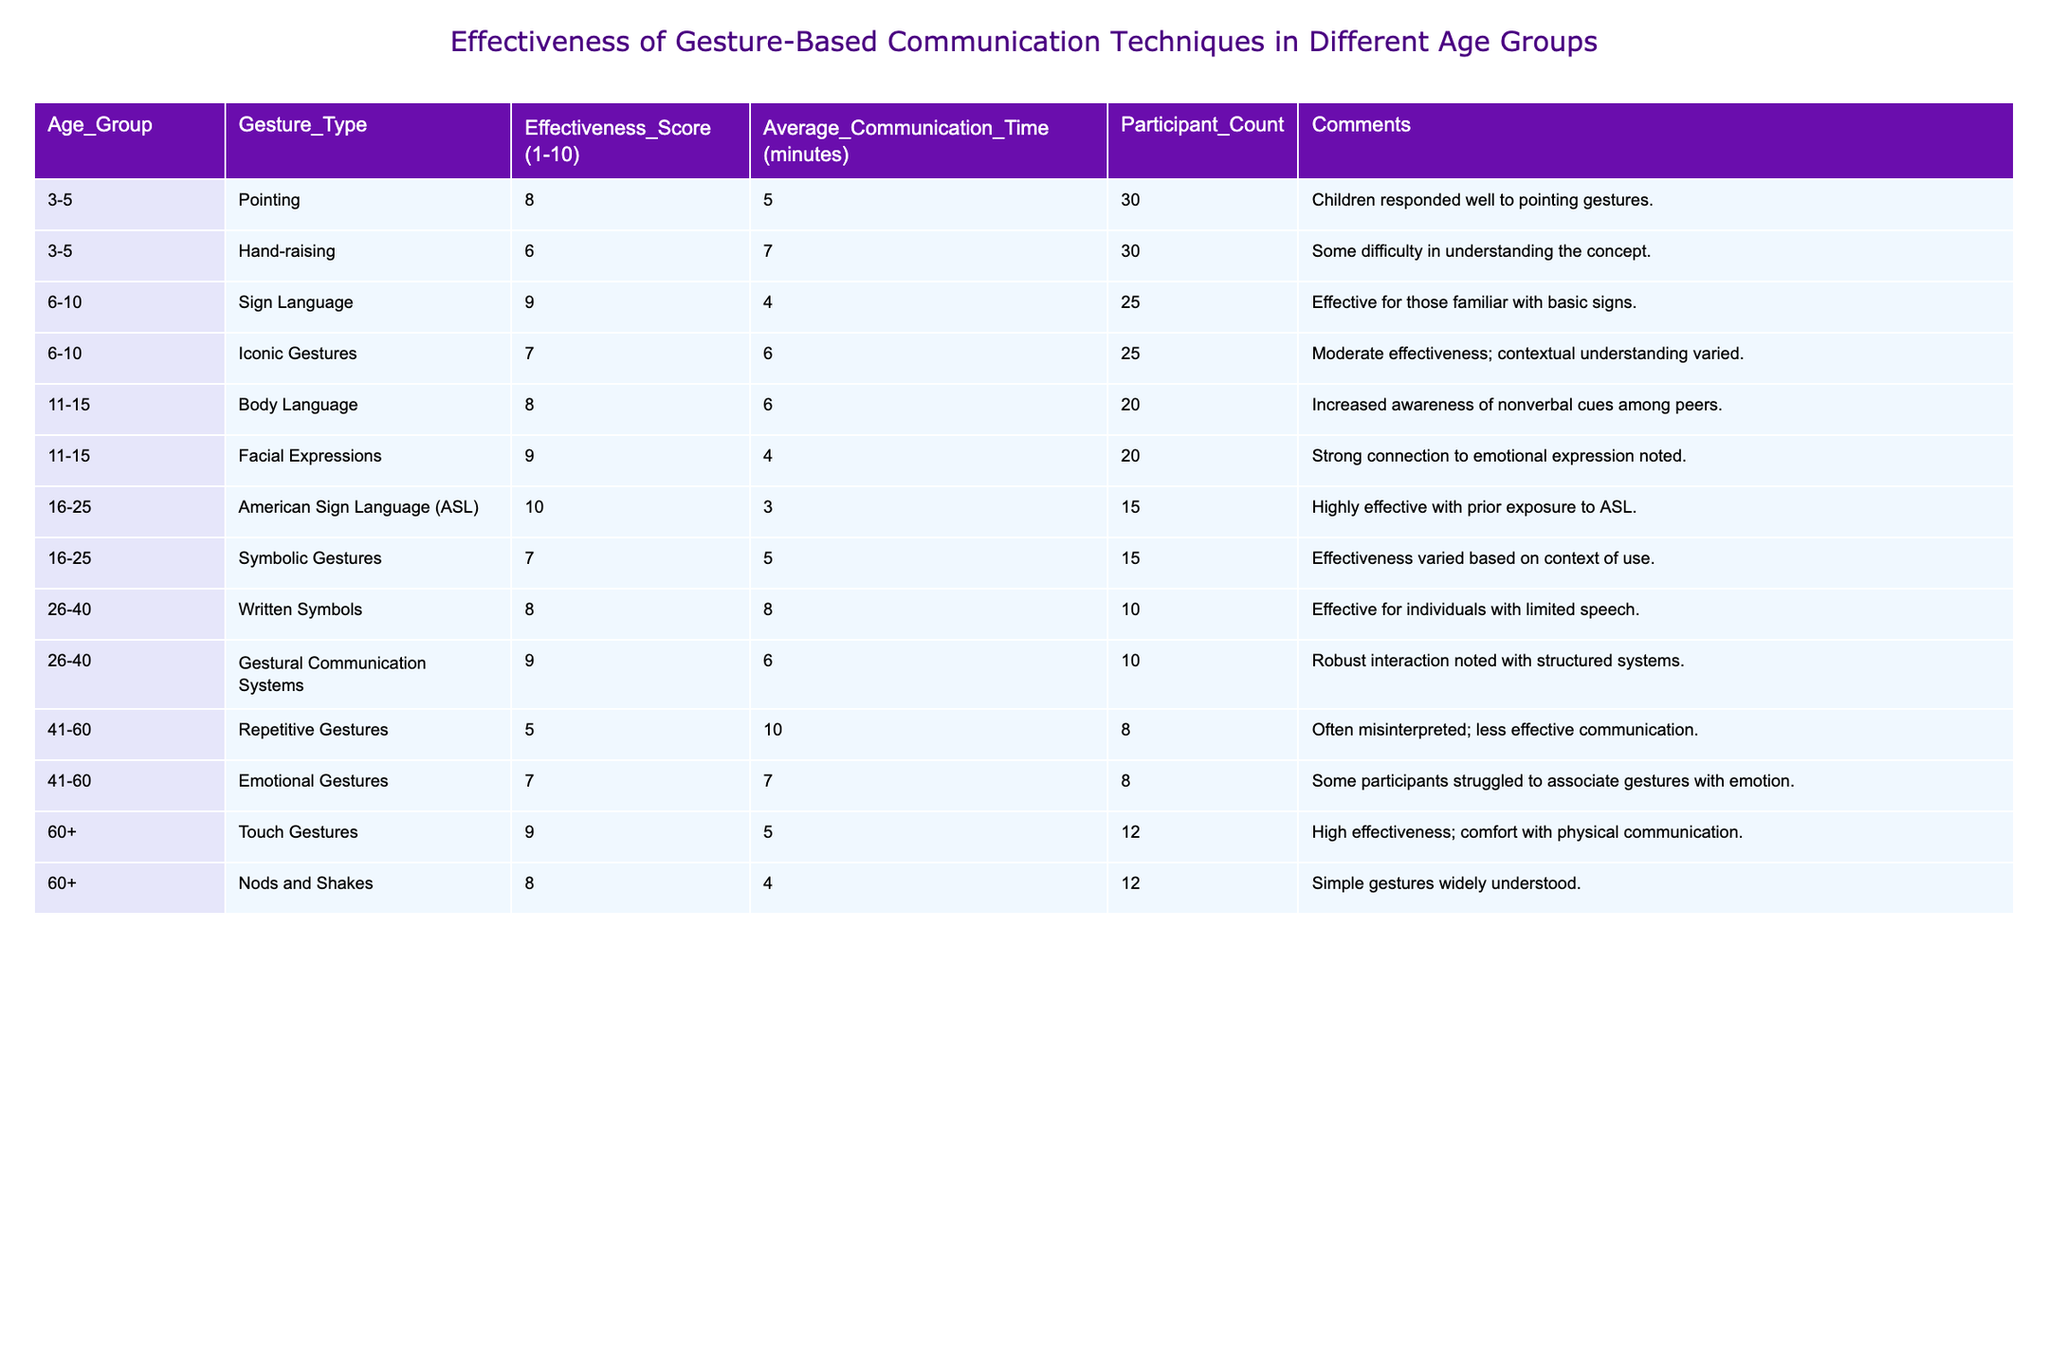What is the effectiveness score for Sign Language in the 6-10 age group? The effectiveness score for Sign Language in the 6-10 age group is directly found in the table's corresponding row. It shows as 9.
Answer: 9 Which gesture type has the highest effectiveness score among the age group 16-25? The age group 16-25 has American Sign Language (ASL) with the highest effectiveness score of 10. This is observed by comparing the scores of both gesture types under that age group.
Answer: 10 What is the average communication time for the gesture type 'Written Symbols'? The communication time for 'Written Symbols' is 8 minutes, as listed in the corresponding row. Thus, the average communication time is simply this value.
Answer: 8 How many participants were involved in the study for the gesture type 'Emotional Gestures'? The table shows that there were 8 participants involved for 'Emotional Gestures' in the age group 41-60, as indicated in the 'Participant Count' column.
Answer: 8 Which age group has the lowest average communication time and what is that time? Age group 16-25 has the lowest average communication time of 3 minutes for American Sign Language (ASL), compared to other groups, found by scanning the communication time values and identifying the minimum.
Answer: 3 Is there any gesture type with a score of 5 or lower in the age group 41-60? Yes, there is a gesture type 'Repetitive Gestures' with an effectiveness score of 5 in the age group 41-60, as directly found in the table.
Answer: Yes What is the average effectiveness score across all age groups? To find the average effectiveness score, we add all the effectiveness scores and divide by the total number of gesture types, which is 10. The sum is 8 + 6 + 9 + 7 + 8 + 9 + 10 + 7 + 8 + 5 + 7 + 9 + 8 = 8.1. Therefore, the average is 8.1.
Answer: 8.1 How many gesture types have an effectiveness score of 9 or higher? There are 5 gesture types with effectiveness scores of 9 or higher (Sign Language, Facial Expressions, ASL, Touch Gestures, and Body Language). This can be counted by checking each effectiveness score to see if it meets or exceeds 9.
Answer: 5 Which gesture type has the most participant count and what is that count? The gesture type 'Pointing' has the highest participant count at 30, as indicated in its corresponding row in the table.
Answer: 30 